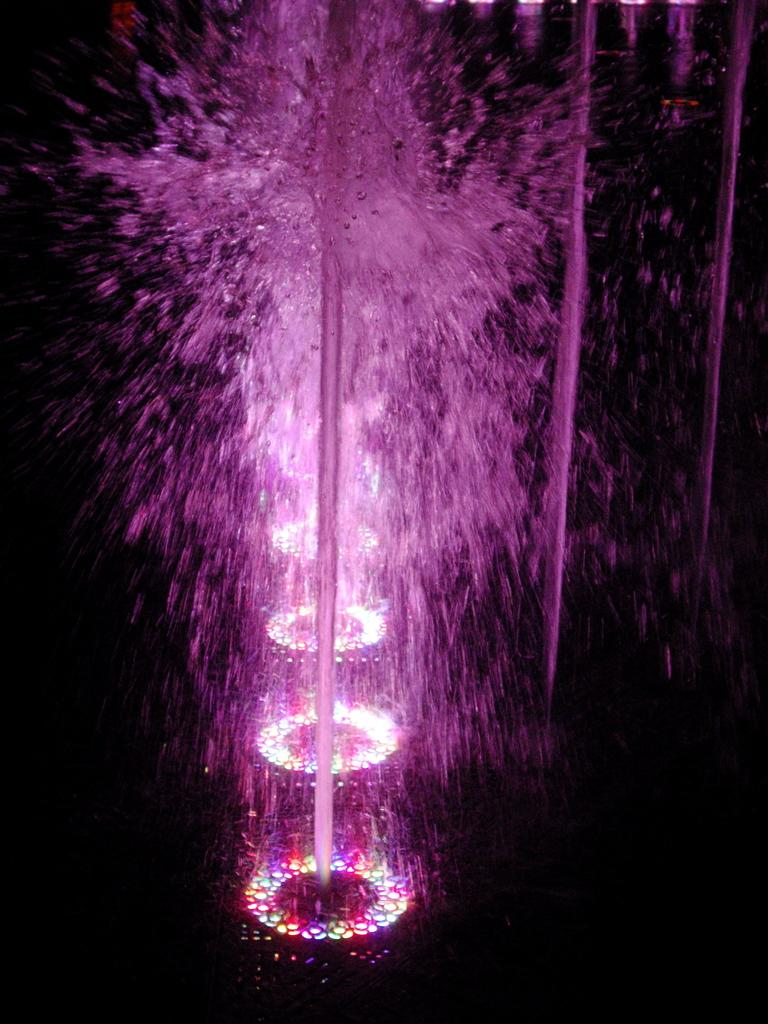What is the main subject of the image? The main subject of the image is a water fountain. What feature of the water fountain is mentioned in the facts? The water fountain has pink color lights. When was the image taken? The image was taken during nighttime. How many geese are visible near the water fountain in the image? There are no geese present in the image. What is the best way to reach the top of the slope near the water fountain in the image? There is no slope mentioned in the facts, and the image does not show any geese or a way to reach the top of a slope. 